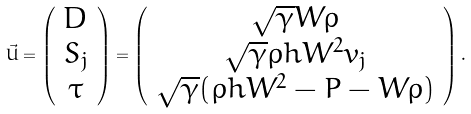<formula> <loc_0><loc_0><loc_500><loc_500>\vec { U } = \left ( \begin{array} { c } D \\ S _ { j } \\ \tau \end{array} \right ) = \left ( \begin{array} { c } \sqrt { \gamma } W \rho \\ \sqrt { \gamma } \rho h W ^ { 2 } v _ { j } \\ \sqrt { \gamma } ( \rho h W ^ { 2 } - P - W \rho ) \end{array} \right ) .</formula> 